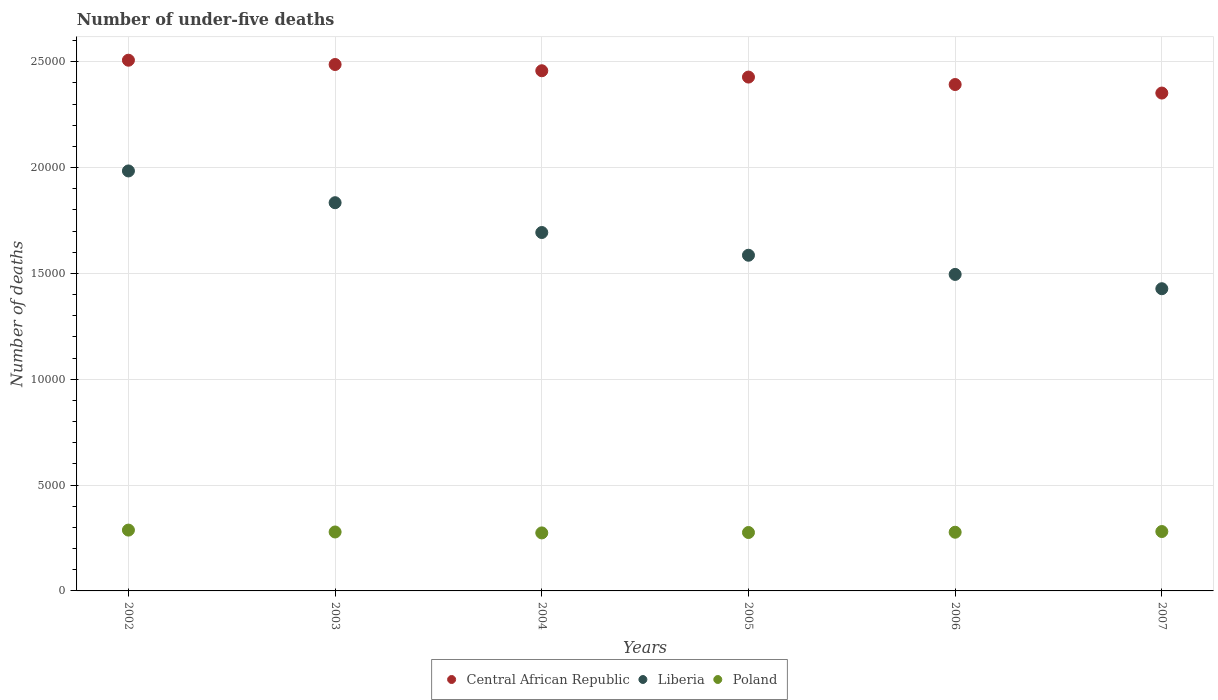How many different coloured dotlines are there?
Offer a terse response. 3. Is the number of dotlines equal to the number of legend labels?
Ensure brevity in your answer.  Yes. What is the number of under-five deaths in Liberia in 2004?
Make the answer very short. 1.69e+04. Across all years, what is the maximum number of under-five deaths in Central African Republic?
Give a very brief answer. 2.51e+04. Across all years, what is the minimum number of under-five deaths in Central African Republic?
Offer a terse response. 2.35e+04. In which year was the number of under-five deaths in Central African Republic minimum?
Make the answer very short. 2007. What is the total number of under-five deaths in Liberia in the graph?
Ensure brevity in your answer.  1.00e+05. What is the difference between the number of under-five deaths in Poland in 2005 and that in 2006?
Make the answer very short. -13. What is the difference between the number of under-five deaths in Central African Republic in 2004 and the number of under-five deaths in Liberia in 2002?
Offer a terse response. 4734. What is the average number of under-five deaths in Central African Republic per year?
Ensure brevity in your answer.  2.44e+04. In the year 2003, what is the difference between the number of under-five deaths in Liberia and number of under-five deaths in Central African Republic?
Make the answer very short. -6530. In how many years, is the number of under-five deaths in Poland greater than 19000?
Keep it short and to the point. 0. What is the ratio of the number of under-five deaths in Poland in 2003 to that in 2005?
Offer a very short reply. 1.01. Is the difference between the number of under-five deaths in Liberia in 2003 and 2007 greater than the difference between the number of under-five deaths in Central African Republic in 2003 and 2007?
Keep it short and to the point. Yes. What is the difference between the highest and the second highest number of under-five deaths in Liberia?
Provide a short and direct response. 1501. What is the difference between the highest and the lowest number of under-five deaths in Poland?
Offer a terse response. 133. In how many years, is the number of under-five deaths in Poland greater than the average number of under-five deaths in Poland taken over all years?
Offer a very short reply. 2. Is the sum of the number of under-five deaths in Central African Republic in 2003 and 2004 greater than the maximum number of under-five deaths in Liberia across all years?
Your answer should be very brief. Yes. Is it the case that in every year, the sum of the number of under-five deaths in Liberia and number of under-five deaths in Central African Republic  is greater than the number of under-five deaths in Poland?
Provide a short and direct response. Yes. Does the number of under-five deaths in Poland monotonically increase over the years?
Offer a terse response. No. Is the number of under-five deaths in Poland strictly greater than the number of under-five deaths in Liberia over the years?
Provide a succinct answer. No. How many dotlines are there?
Offer a terse response. 3. What is the difference between two consecutive major ticks on the Y-axis?
Provide a short and direct response. 5000. Does the graph contain any zero values?
Give a very brief answer. No. Does the graph contain grids?
Keep it short and to the point. Yes. Where does the legend appear in the graph?
Keep it short and to the point. Bottom center. How many legend labels are there?
Make the answer very short. 3. What is the title of the graph?
Give a very brief answer. Number of under-five deaths. What is the label or title of the X-axis?
Ensure brevity in your answer.  Years. What is the label or title of the Y-axis?
Keep it short and to the point. Number of deaths. What is the Number of deaths in Central African Republic in 2002?
Offer a very short reply. 2.51e+04. What is the Number of deaths of Liberia in 2002?
Your answer should be compact. 1.98e+04. What is the Number of deaths of Poland in 2002?
Ensure brevity in your answer.  2874. What is the Number of deaths in Central African Republic in 2003?
Keep it short and to the point. 2.49e+04. What is the Number of deaths in Liberia in 2003?
Ensure brevity in your answer.  1.83e+04. What is the Number of deaths in Poland in 2003?
Provide a succinct answer. 2785. What is the Number of deaths of Central African Republic in 2004?
Make the answer very short. 2.46e+04. What is the Number of deaths of Liberia in 2004?
Keep it short and to the point. 1.69e+04. What is the Number of deaths of Poland in 2004?
Your answer should be very brief. 2741. What is the Number of deaths in Central African Republic in 2005?
Your answer should be very brief. 2.43e+04. What is the Number of deaths of Liberia in 2005?
Keep it short and to the point. 1.59e+04. What is the Number of deaths of Poland in 2005?
Offer a very short reply. 2760. What is the Number of deaths in Central African Republic in 2006?
Ensure brevity in your answer.  2.39e+04. What is the Number of deaths of Liberia in 2006?
Make the answer very short. 1.50e+04. What is the Number of deaths of Poland in 2006?
Your answer should be compact. 2773. What is the Number of deaths of Central African Republic in 2007?
Offer a terse response. 2.35e+04. What is the Number of deaths in Liberia in 2007?
Make the answer very short. 1.43e+04. What is the Number of deaths in Poland in 2007?
Your answer should be very brief. 2806. Across all years, what is the maximum Number of deaths in Central African Republic?
Give a very brief answer. 2.51e+04. Across all years, what is the maximum Number of deaths in Liberia?
Keep it short and to the point. 1.98e+04. Across all years, what is the maximum Number of deaths in Poland?
Your answer should be very brief. 2874. Across all years, what is the minimum Number of deaths in Central African Republic?
Provide a succinct answer. 2.35e+04. Across all years, what is the minimum Number of deaths of Liberia?
Your answer should be very brief. 1.43e+04. Across all years, what is the minimum Number of deaths of Poland?
Make the answer very short. 2741. What is the total Number of deaths in Central African Republic in the graph?
Offer a terse response. 1.46e+05. What is the total Number of deaths in Liberia in the graph?
Offer a very short reply. 1.00e+05. What is the total Number of deaths in Poland in the graph?
Ensure brevity in your answer.  1.67e+04. What is the difference between the Number of deaths in Central African Republic in 2002 and that in 2003?
Provide a short and direct response. 203. What is the difference between the Number of deaths of Liberia in 2002 and that in 2003?
Keep it short and to the point. 1501. What is the difference between the Number of deaths of Poland in 2002 and that in 2003?
Give a very brief answer. 89. What is the difference between the Number of deaths in Central African Republic in 2002 and that in 2004?
Keep it short and to the point. 498. What is the difference between the Number of deaths in Liberia in 2002 and that in 2004?
Provide a short and direct response. 2909. What is the difference between the Number of deaths of Poland in 2002 and that in 2004?
Give a very brief answer. 133. What is the difference between the Number of deaths in Central African Republic in 2002 and that in 2005?
Your response must be concise. 797. What is the difference between the Number of deaths of Liberia in 2002 and that in 2005?
Keep it short and to the point. 3983. What is the difference between the Number of deaths in Poland in 2002 and that in 2005?
Your answer should be compact. 114. What is the difference between the Number of deaths of Central African Republic in 2002 and that in 2006?
Keep it short and to the point. 1149. What is the difference between the Number of deaths in Liberia in 2002 and that in 2006?
Offer a very short reply. 4889. What is the difference between the Number of deaths in Poland in 2002 and that in 2006?
Your response must be concise. 101. What is the difference between the Number of deaths in Central African Republic in 2002 and that in 2007?
Give a very brief answer. 1552. What is the difference between the Number of deaths of Liberia in 2002 and that in 2007?
Your answer should be compact. 5565. What is the difference between the Number of deaths in Central African Republic in 2003 and that in 2004?
Your response must be concise. 295. What is the difference between the Number of deaths of Liberia in 2003 and that in 2004?
Give a very brief answer. 1408. What is the difference between the Number of deaths of Poland in 2003 and that in 2004?
Give a very brief answer. 44. What is the difference between the Number of deaths in Central African Republic in 2003 and that in 2005?
Give a very brief answer. 594. What is the difference between the Number of deaths in Liberia in 2003 and that in 2005?
Ensure brevity in your answer.  2482. What is the difference between the Number of deaths in Central African Republic in 2003 and that in 2006?
Provide a succinct answer. 946. What is the difference between the Number of deaths in Liberia in 2003 and that in 2006?
Ensure brevity in your answer.  3388. What is the difference between the Number of deaths in Poland in 2003 and that in 2006?
Your answer should be very brief. 12. What is the difference between the Number of deaths of Central African Republic in 2003 and that in 2007?
Provide a succinct answer. 1349. What is the difference between the Number of deaths of Liberia in 2003 and that in 2007?
Ensure brevity in your answer.  4064. What is the difference between the Number of deaths of Poland in 2003 and that in 2007?
Your answer should be compact. -21. What is the difference between the Number of deaths of Central African Republic in 2004 and that in 2005?
Provide a succinct answer. 299. What is the difference between the Number of deaths of Liberia in 2004 and that in 2005?
Your response must be concise. 1074. What is the difference between the Number of deaths of Central African Republic in 2004 and that in 2006?
Keep it short and to the point. 651. What is the difference between the Number of deaths in Liberia in 2004 and that in 2006?
Keep it short and to the point. 1980. What is the difference between the Number of deaths of Poland in 2004 and that in 2006?
Offer a terse response. -32. What is the difference between the Number of deaths in Central African Republic in 2004 and that in 2007?
Your response must be concise. 1054. What is the difference between the Number of deaths in Liberia in 2004 and that in 2007?
Your response must be concise. 2656. What is the difference between the Number of deaths of Poland in 2004 and that in 2007?
Offer a terse response. -65. What is the difference between the Number of deaths in Central African Republic in 2005 and that in 2006?
Provide a short and direct response. 352. What is the difference between the Number of deaths of Liberia in 2005 and that in 2006?
Make the answer very short. 906. What is the difference between the Number of deaths in Poland in 2005 and that in 2006?
Your answer should be very brief. -13. What is the difference between the Number of deaths in Central African Republic in 2005 and that in 2007?
Keep it short and to the point. 755. What is the difference between the Number of deaths of Liberia in 2005 and that in 2007?
Give a very brief answer. 1582. What is the difference between the Number of deaths in Poland in 2005 and that in 2007?
Ensure brevity in your answer.  -46. What is the difference between the Number of deaths in Central African Republic in 2006 and that in 2007?
Your answer should be very brief. 403. What is the difference between the Number of deaths in Liberia in 2006 and that in 2007?
Your response must be concise. 676. What is the difference between the Number of deaths of Poland in 2006 and that in 2007?
Give a very brief answer. -33. What is the difference between the Number of deaths in Central African Republic in 2002 and the Number of deaths in Liberia in 2003?
Keep it short and to the point. 6733. What is the difference between the Number of deaths in Central African Republic in 2002 and the Number of deaths in Poland in 2003?
Offer a very short reply. 2.23e+04. What is the difference between the Number of deaths of Liberia in 2002 and the Number of deaths of Poland in 2003?
Provide a succinct answer. 1.71e+04. What is the difference between the Number of deaths of Central African Republic in 2002 and the Number of deaths of Liberia in 2004?
Offer a terse response. 8141. What is the difference between the Number of deaths of Central African Republic in 2002 and the Number of deaths of Poland in 2004?
Your answer should be compact. 2.23e+04. What is the difference between the Number of deaths in Liberia in 2002 and the Number of deaths in Poland in 2004?
Your answer should be compact. 1.71e+04. What is the difference between the Number of deaths of Central African Republic in 2002 and the Number of deaths of Liberia in 2005?
Offer a very short reply. 9215. What is the difference between the Number of deaths in Central African Republic in 2002 and the Number of deaths in Poland in 2005?
Provide a short and direct response. 2.23e+04. What is the difference between the Number of deaths in Liberia in 2002 and the Number of deaths in Poland in 2005?
Provide a succinct answer. 1.71e+04. What is the difference between the Number of deaths in Central African Republic in 2002 and the Number of deaths in Liberia in 2006?
Offer a terse response. 1.01e+04. What is the difference between the Number of deaths of Central African Republic in 2002 and the Number of deaths of Poland in 2006?
Provide a short and direct response. 2.23e+04. What is the difference between the Number of deaths of Liberia in 2002 and the Number of deaths of Poland in 2006?
Your response must be concise. 1.71e+04. What is the difference between the Number of deaths of Central African Republic in 2002 and the Number of deaths of Liberia in 2007?
Keep it short and to the point. 1.08e+04. What is the difference between the Number of deaths of Central African Republic in 2002 and the Number of deaths of Poland in 2007?
Your response must be concise. 2.23e+04. What is the difference between the Number of deaths of Liberia in 2002 and the Number of deaths of Poland in 2007?
Give a very brief answer. 1.70e+04. What is the difference between the Number of deaths of Central African Republic in 2003 and the Number of deaths of Liberia in 2004?
Give a very brief answer. 7938. What is the difference between the Number of deaths of Central African Republic in 2003 and the Number of deaths of Poland in 2004?
Give a very brief answer. 2.21e+04. What is the difference between the Number of deaths of Liberia in 2003 and the Number of deaths of Poland in 2004?
Your answer should be compact. 1.56e+04. What is the difference between the Number of deaths of Central African Republic in 2003 and the Number of deaths of Liberia in 2005?
Give a very brief answer. 9012. What is the difference between the Number of deaths of Central African Republic in 2003 and the Number of deaths of Poland in 2005?
Ensure brevity in your answer.  2.21e+04. What is the difference between the Number of deaths in Liberia in 2003 and the Number of deaths in Poland in 2005?
Provide a succinct answer. 1.56e+04. What is the difference between the Number of deaths of Central African Republic in 2003 and the Number of deaths of Liberia in 2006?
Give a very brief answer. 9918. What is the difference between the Number of deaths of Central African Republic in 2003 and the Number of deaths of Poland in 2006?
Keep it short and to the point. 2.21e+04. What is the difference between the Number of deaths in Liberia in 2003 and the Number of deaths in Poland in 2006?
Offer a very short reply. 1.56e+04. What is the difference between the Number of deaths in Central African Republic in 2003 and the Number of deaths in Liberia in 2007?
Keep it short and to the point. 1.06e+04. What is the difference between the Number of deaths of Central African Republic in 2003 and the Number of deaths of Poland in 2007?
Offer a very short reply. 2.21e+04. What is the difference between the Number of deaths in Liberia in 2003 and the Number of deaths in Poland in 2007?
Provide a succinct answer. 1.55e+04. What is the difference between the Number of deaths in Central African Republic in 2004 and the Number of deaths in Liberia in 2005?
Give a very brief answer. 8717. What is the difference between the Number of deaths in Central African Republic in 2004 and the Number of deaths in Poland in 2005?
Keep it short and to the point. 2.18e+04. What is the difference between the Number of deaths in Liberia in 2004 and the Number of deaths in Poland in 2005?
Keep it short and to the point. 1.42e+04. What is the difference between the Number of deaths of Central African Republic in 2004 and the Number of deaths of Liberia in 2006?
Your response must be concise. 9623. What is the difference between the Number of deaths of Central African Republic in 2004 and the Number of deaths of Poland in 2006?
Your answer should be very brief. 2.18e+04. What is the difference between the Number of deaths in Liberia in 2004 and the Number of deaths in Poland in 2006?
Your answer should be very brief. 1.42e+04. What is the difference between the Number of deaths in Central African Republic in 2004 and the Number of deaths in Liberia in 2007?
Keep it short and to the point. 1.03e+04. What is the difference between the Number of deaths of Central African Republic in 2004 and the Number of deaths of Poland in 2007?
Offer a very short reply. 2.18e+04. What is the difference between the Number of deaths in Liberia in 2004 and the Number of deaths in Poland in 2007?
Your answer should be very brief. 1.41e+04. What is the difference between the Number of deaths of Central African Republic in 2005 and the Number of deaths of Liberia in 2006?
Your response must be concise. 9324. What is the difference between the Number of deaths of Central African Republic in 2005 and the Number of deaths of Poland in 2006?
Offer a terse response. 2.15e+04. What is the difference between the Number of deaths in Liberia in 2005 and the Number of deaths in Poland in 2006?
Keep it short and to the point. 1.31e+04. What is the difference between the Number of deaths in Central African Republic in 2005 and the Number of deaths in Liberia in 2007?
Provide a short and direct response. 10000. What is the difference between the Number of deaths in Central African Republic in 2005 and the Number of deaths in Poland in 2007?
Provide a short and direct response. 2.15e+04. What is the difference between the Number of deaths in Liberia in 2005 and the Number of deaths in Poland in 2007?
Provide a short and direct response. 1.31e+04. What is the difference between the Number of deaths of Central African Republic in 2006 and the Number of deaths of Liberia in 2007?
Ensure brevity in your answer.  9648. What is the difference between the Number of deaths of Central African Republic in 2006 and the Number of deaths of Poland in 2007?
Offer a terse response. 2.11e+04. What is the difference between the Number of deaths of Liberia in 2006 and the Number of deaths of Poland in 2007?
Give a very brief answer. 1.21e+04. What is the average Number of deaths in Central African Republic per year?
Offer a terse response. 2.44e+04. What is the average Number of deaths of Liberia per year?
Provide a short and direct response. 1.67e+04. What is the average Number of deaths in Poland per year?
Provide a succinct answer. 2789.83. In the year 2002, what is the difference between the Number of deaths of Central African Republic and Number of deaths of Liberia?
Offer a terse response. 5232. In the year 2002, what is the difference between the Number of deaths in Central African Republic and Number of deaths in Poland?
Your response must be concise. 2.22e+04. In the year 2002, what is the difference between the Number of deaths of Liberia and Number of deaths of Poland?
Provide a succinct answer. 1.70e+04. In the year 2003, what is the difference between the Number of deaths of Central African Republic and Number of deaths of Liberia?
Your response must be concise. 6530. In the year 2003, what is the difference between the Number of deaths of Central African Republic and Number of deaths of Poland?
Make the answer very short. 2.21e+04. In the year 2003, what is the difference between the Number of deaths in Liberia and Number of deaths in Poland?
Offer a terse response. 1.56e+04. In the year 2004, what is the difference between the Number of deaths of Central African Republic and Number of deaths of Liberia?
Offer a terse response. 7643. In the year 2004, what is the difference between the Number of deaths in Central African Republic and Number of deaths in Poland?
Offer a very short reply. 2.18e+04. In the year 2004, what is the difference between the Number of deaths of Liberia and Number of deaths of Poland?
Offer a terse response. 1.42e+04. In the year 2005, what is the difference between the Number of deaths in Central African Republic and Number of deaths in Liberia?
Keep it short and to the point. 8418. In the year 2005, what is the difference between the Number of deaths of Central African Republic and Number of deaths of Poland?
Your answer should be very brief. 2.15e+04. In the year 2005, what is the difference between the Number of deaths of Liberia and Number of deaths of Poland?
Your answer should be compact. 1.31e+04. In the year 2006, what is the difference between the Number of deaths in Central African Republic and Number of deaths in Liberia?
Provide a short and direct response. 8972. In the year 2006, what is the difference between the Number of deaths in Central African Republic and Number of deaths in Poland?
Offer a very short reply. 2.12e+04. In the year 2006, what is the difference between the Number of deaths of Liberia and Number of deaths of Poland?
Keep it short and to the point. 1.22e+04. In the year 2007, what is the difference between the Number of deaths of Central African Republic and Number of deaths of Liberia?
Ensure brevity in your answer.  9245. In the year 2007, what is the difference between the Number of deaths of Central African Republic and Number of deaths of Poland?
Give a very brief answer. 2.07e+04. In the year 2007, what is the difference between the Number of deaths of Liberia and Number of deaths of Poland?
Ensure brevity in your answer.  1.15e+04. What is the ratio of the Number of deaths in Central African Republic in 2002 to that in 2003?
Offer a very short reply. 1.01. What is the ratio of the Number of deaths in Liberia in 2002 to that in 2003?
Your response must be concise. 1.08. What is the ratio of the Number of deaths in Poland in 2002 to that in 2003?
Give a very brief answer. 1.03. What is the ratio of the Number of deaths in Central African Republic in 2002 to that in 2004?
Provide a short and direct response. 1.02. What is the ratio of the Number of deaths of Liberia in 2002 to that in 2004?
Provide a short and direct response. 1.17. What is the ratio of the Number of deaths in Poland in 2002 to that in 2004?
Your answer should be very brief. 1.05. What is the ratio of the Number of deaths of Central African Republic in 2002 to that in 2005?
Ensure brevity in your answer.  1.03. What is the ratio of the Number of deaths in Liberia in 2002 to that in 2005?
Make the answer very short. 1.25. What is the ratio of the Number of deaths of Poland in 2002 to that in 2005?
Keep it short and to the point. 1.04. What is the ratio of the Number of deaths in Central African Republic in 2002 to that in 2006?
Provide a short and direct response. 1.05. What is the ratio of the Number of deaths in Liberia in 2002 to that in 2006?
Make the answer very short. 1.33. What is the ratio of the Number of deaths of Poland in 2002 to that in 2006?
Your response must be concise. 1.04. What is the ratio of the Number of deaths of Central African Republic in 2002 to that in 2007?
Give a very brief answer. 1.07. What is the ratio of the Number of deaths in Liberia in 2002 to that in 2007?
Your response must be concise. 1.39. What is the ratio of the Number of deaths in Poland in 2002 to that in 2007?
Your answer should be compact. 1.02. What is the ratio of the Number of deaths of Central African Republic in 2003 to that in 2004?
Provide a succinct answer. 1.01. What is the ratio of the Number of deaths of Liberia in 2003 to that in 2004?
Your response must be concise. 1.08. What is the ratio of the Number of deaths of Poland in 2003 to that in 2004?
Your response must be concise. 1.02. What is the ratio of the Number of deaths of Central African Republic in 2003 to that in 2005?
Provide a short and direct response. 1.02. What is the ratio of the Number of deaths of Liberia in 2003 to that in 2005?
Ensure brevity in your answer.  1.16. What is the ratio of the Number of deaths of Poland in 2003 to that in 2005?
Offer a very short reply. 1.01. What is the ratio of the Number of deaths of Central African Republic in 2003 to that in 2006?
Ensure brevity in your answer.  1.04. What is the ratio of the Number of deaths of Liberia in 2003 to that in 2006?
Your response must be concise. 1.23. What is the ratio of the Number of deaths of Poland in 2003 to that in 2006?
Give a very brief answer. 1. What is the ratio of the Number of deaths of Central African Republic in 2003 to that in 2007?
Give a very brief answer. 1.06. What is the ratio of the Number of deaths of Liberia in 2003 to that in 2007?
Ensure brevity in your answer.  1.28. What is the ratio of the Number of deaths of Central African Republic in 2004 to that in 2005?
Keep it short and to the point. 1.01. What is the ratio of the Number of deaths in Liberia in 2004 to that in 2005?
Offer a very short reply. 1.07. What is the ratio of the Number of deaths of Central African Republic in 2004 to that in 2006?
Keep it short and to the point. 1.03. What is the ratio of the Number of deaths in Liberia in 2004 to that in 2006?
Provide a succinct answer. 1.13. What is the ratio of the Number of deaths of Poland in 2004 to that in 2006?
Keep it short and to the point. 0.99. What is the ratio of the Number of deaths in Central African Republic in 2004 to that in 2007?
Offer a terse response. 1.04. What is the ratio of the Number of deaths of Liberia in 2004 to that in 2007?
Make the answer very short. 1.19. What is the ratio of the Number of deaths in Poland in 2004 to that in 2007?
Your answer should be very brief. 0.98. What is the ratio of the Number of deaths of Central African Republic in 2005 to that in 2006?
Your answer should be very brief. 1.01. What is the ratio of the Number of deaths in Liberia in 2005 to that in 2006?
Give a very brief answer. 1.06. What is the ratio of the Number of deaths of Central African Republic in 2005 to that in 2007?
Provide a short and direct response. 1.03. What is the ratio of the Number of deaths in Liberia in 2005 to that in 2007?
Provide a short and direct response. 1.11. What is the ratio of the Number of deaths in Poland in 2005 to that in 2007?
Offer a very short reply. 0.98. What is the ratio of the Number of deaths in Central African Republic in 2006 to that in 2007?
Make the answer very short. 1.02. What is the ratio of the Number of deaths of Liberia in 2006 to that in 2007?
Your answer should be very brief. 1.05. What is the difference between the highest and the second highest Number of deaths in Central African Republic?
Give a very brief answer. 203. What is the difference between the highest and the second highest Number of deaths in Liberia?
Offer a terse response. 1501. What is the difference between the highest and the second highest Number of deaths in Poland?
Give a very brief answer. 68. What is the difference between the highest and the lowest Number of deaths of Central African Republic?
Ensure brevity in your answer.  1552. What is the difference between the highest and the lowest Number of deaths in Liberia?
Keep it short and to the point. 5565. What is the difference between the highest and the lowest Number of deaths of Poland?
Your answer should be very brief. 133. 